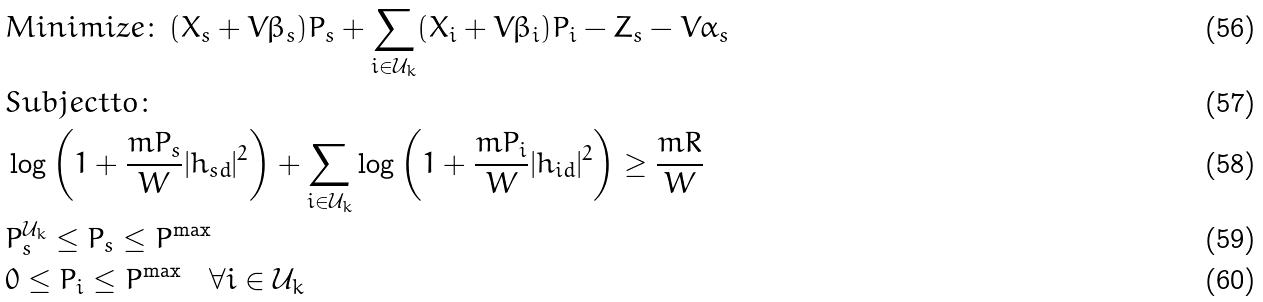Convert formula to latex. <formula><loc_0><loc_0><loc_500><loc_500>& M i n i m i z e \colon \, ( X _ { s } + V \beta _ { s } ) P _ { s } + \sum _ { i \in \mathcal { U } _ { k } } ( X _ { i } + V \beta _ { i } ) P _ { i } - Z _ { s } - V \alpha _ { s } \\ & S u b j e c t t o \colon \\ & \log \left ( 1 + \frac { m P _ { s } } { W } | h _ { s d } | ^ { 2 } \right ) + \sum _ { i \in \mathcal { U } _ { k } } \log \left ( 1 + \frac { m P _ { i } } { W } | h _ { i d } | ^ { 2 } \right ) \geq \frac { m R } { W } \\ & P _ { s } ^ { \mathcal { U } _ { k } } \leq P _ { s } \leq P ^ { \max } \\ & 0 \leq P _ { i } \leq P ^ { \max } \quad \forall i \in \mathcal { U } _ { k }</formula> 